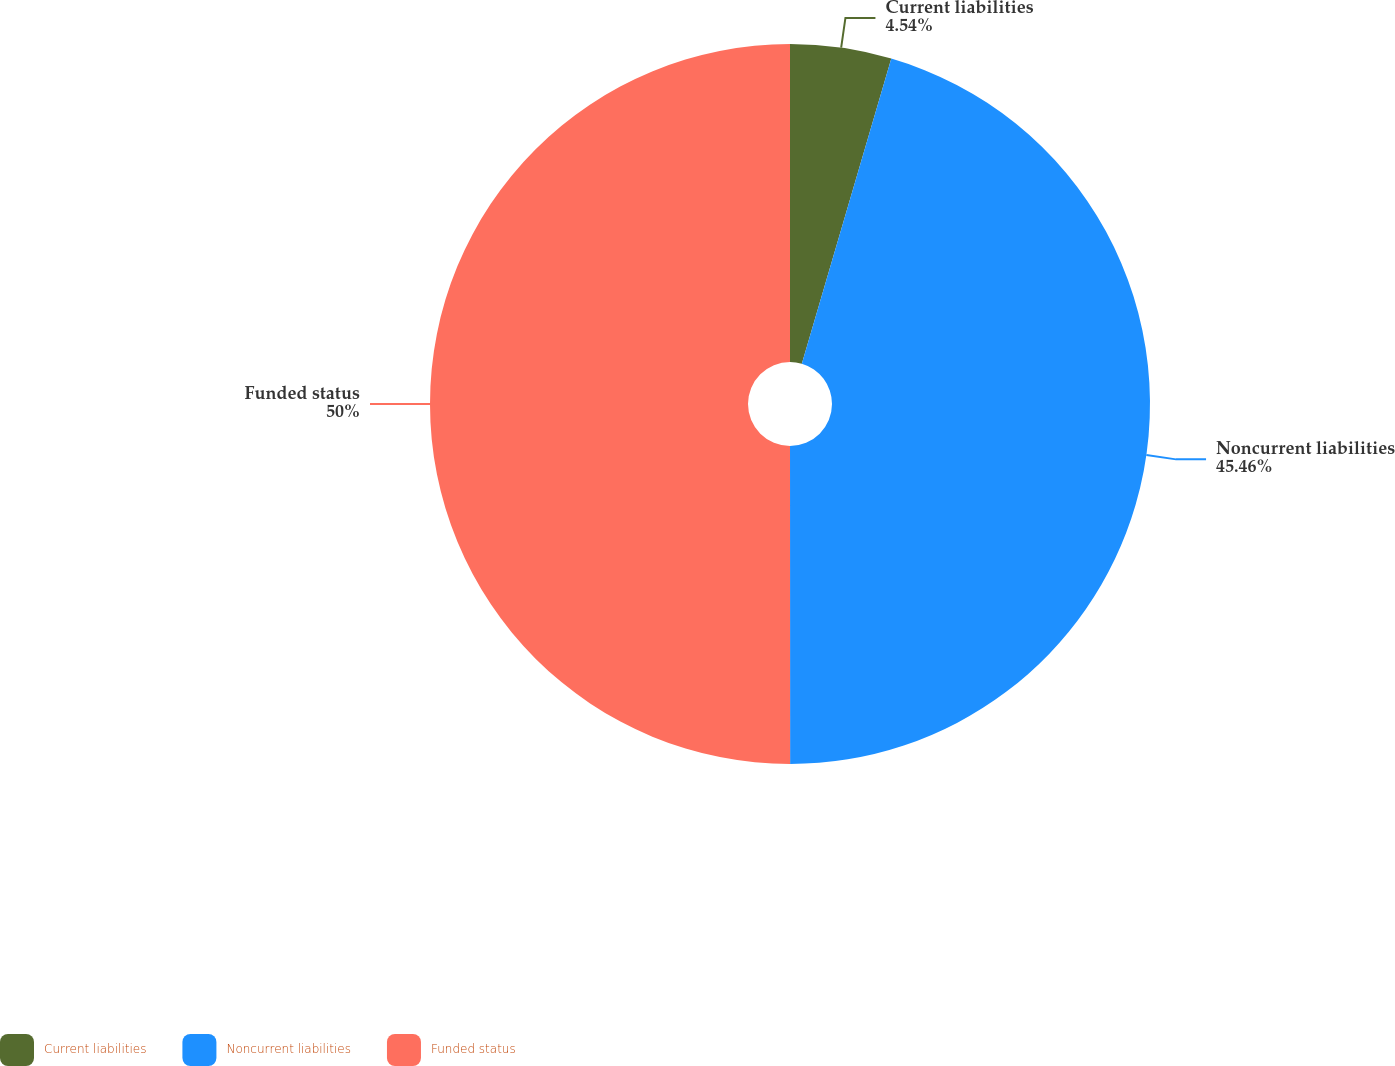Convert chart to OTSL. <chart><loc_0><loc_0><loc_500><loc_500><pie_chart><fcel>Current liabilities<fcel>Noncurrent liabilities<fcel>Funded status<nl><fcel>4.54%<fcel>45.46%<fcel>50.01%<nl></chart> 